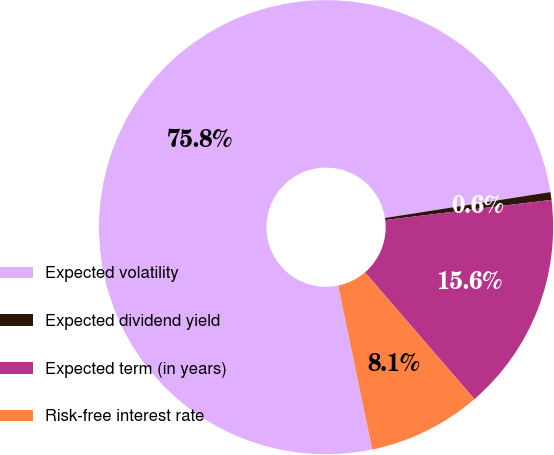<chart> <loc_0><loc_0><loc_500><loc_500><pie_chart><fcel>Expected volatility<fcel>Expected dividend yield<fcel>Expected term (in years)<fcel>Risk-free interest rate<nl><fcel>75.78%<fcel>0.55%<fcel>15.59%<fcel>8.07%<nl></chart> 